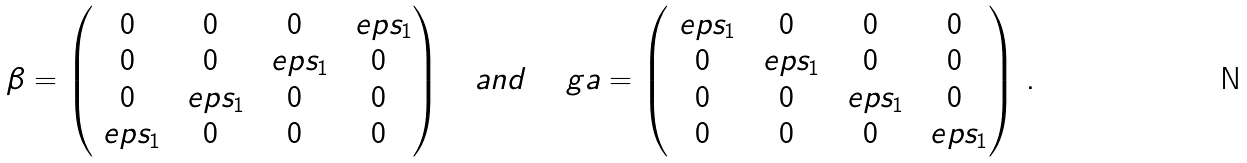Convert formula to latex. <formula><loc_0><loc_0><loc_500><loc_500>\beta = \begin{pmatrix} 0 & 0 & 0 & \ e p s _ { 1 } \\ 0 & 0 & \ e p s _ { 1 } & 0 \\ 0 & \ e p s _ { 1 } & 0 & 0 \\ \ e p s _ { 1 } & 0 & 0 & 0 \end{pmatrix} \quad a n d \quad \ g a = \begin{pmatrix} \ e p s _ { 1 } & 0 & 0 & 0 \\ 0 & \ e p s _ { 1 } & 0 & 0 \\ 0 & 0 & \ e p s _ { 1 } & 0 \\ 0 & 0 & 0 & \ e p s _ { 1 } \end{pmatrix} \, .</formula> 